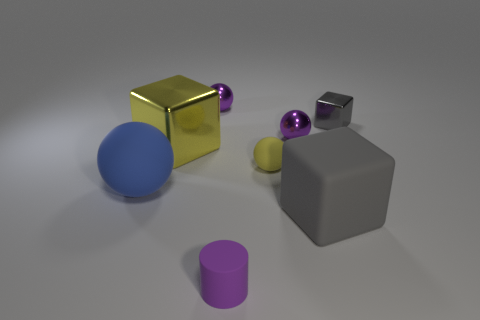What shape is the large gray rubber object to the right of the big yellow metal object? The large gray object to the right of the big yellow metal object is a cube. It has a distinctly geometrical shape with six faces, all of which are squares of the same size. Its edges are sharp and straight, meeting at right angles, which are key characteristics of a cube. 